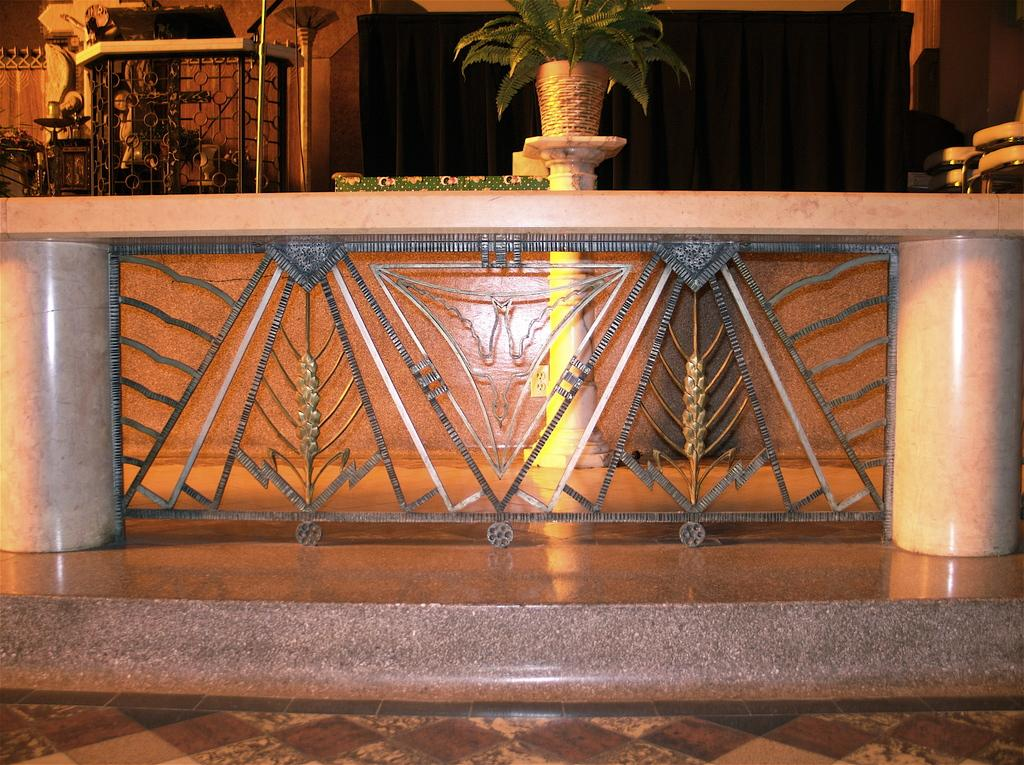What is the main object in the middle of the picture? There is a desk in the middle of the picture. What can be seen on top of the desk? There is a plant pot on top of the desk. What color is the curtain in the background of the picture? There is a black color curtain in the background of the picture. What type of apples are hanging from the curtain in the image? There are no apples or chains present in the image, and therefore no such item can be observed. 